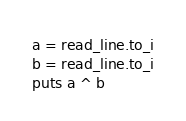<code> <loc_0><loc_0><loc_500><loc_500><_Crystal_>a = read_line.to_i
b = read_line.to_i
puts a ^ b</code> 